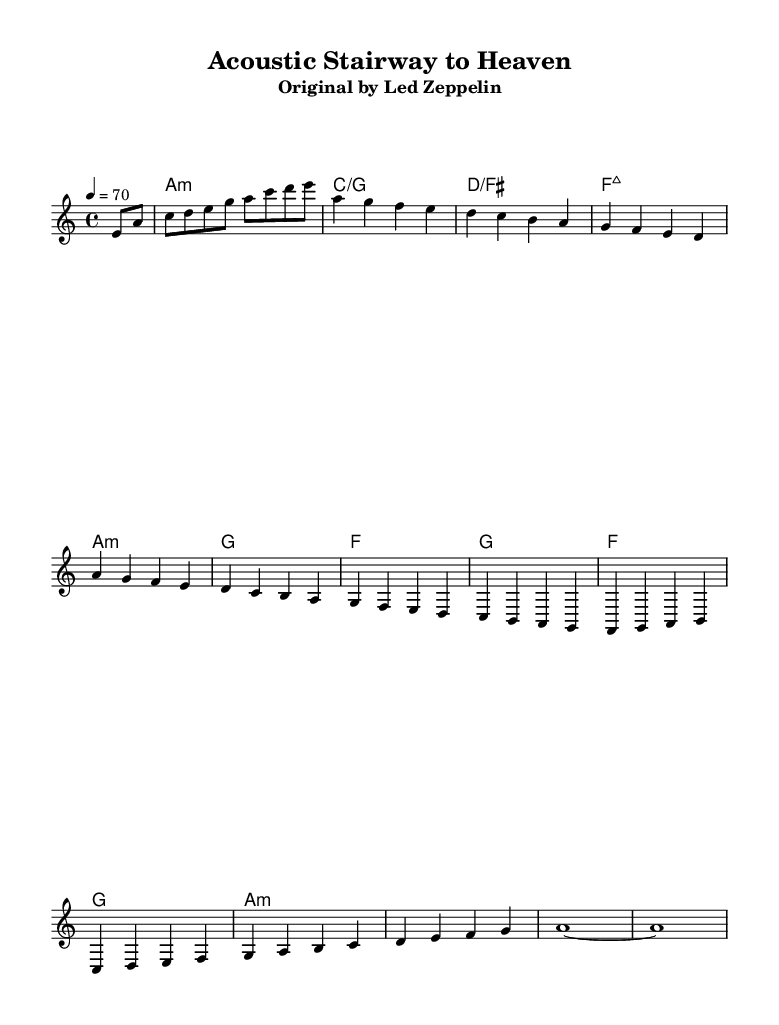What is the key signature of this music? The key signature indicates that the piece is in A minor, which is recognized by the presence of no sharps or flats. This can be identified at the beginning of the sheet music after the clef symbol.
Answer: A minor What is the time signature of this music? The time signature of the piece is 4/4, which means there are four beats in each measure and a quarter note receives one beat. This is typically located at the beginning of the score, near the key signature.
Answer: 4/4 What is the tempo marking for this piece? The tempo marking is 70 beats per minute, indicated by "4 = 70." This means that the quarter note is played at a speed of 70 beats in one minute. This information is usually found at the beginning of the score under the time signature.
Answer: 70 How many measures are in the piece? By counting the individual measures represented in the score, you can see that there are a total of 10 measures. Each measure is separated by vertical lines.
Answer: 10 What type of chords are used in this piece? The chords indicated are primarily folk-style chords, which include minor and major chords, such as A minor, C major, and D major. The presence of these chords can be identified in the chord names written above the staff, indicating the harmonies that accompany the melody.
Answer: Folk-style chords What is the last note of the melody? The last note of the melody is an "a" note, sustained for the entire measure as indicated by the notation. This is determined by looking at the last measure of the guitar part, where the note is held out without further division.
Answer: a 